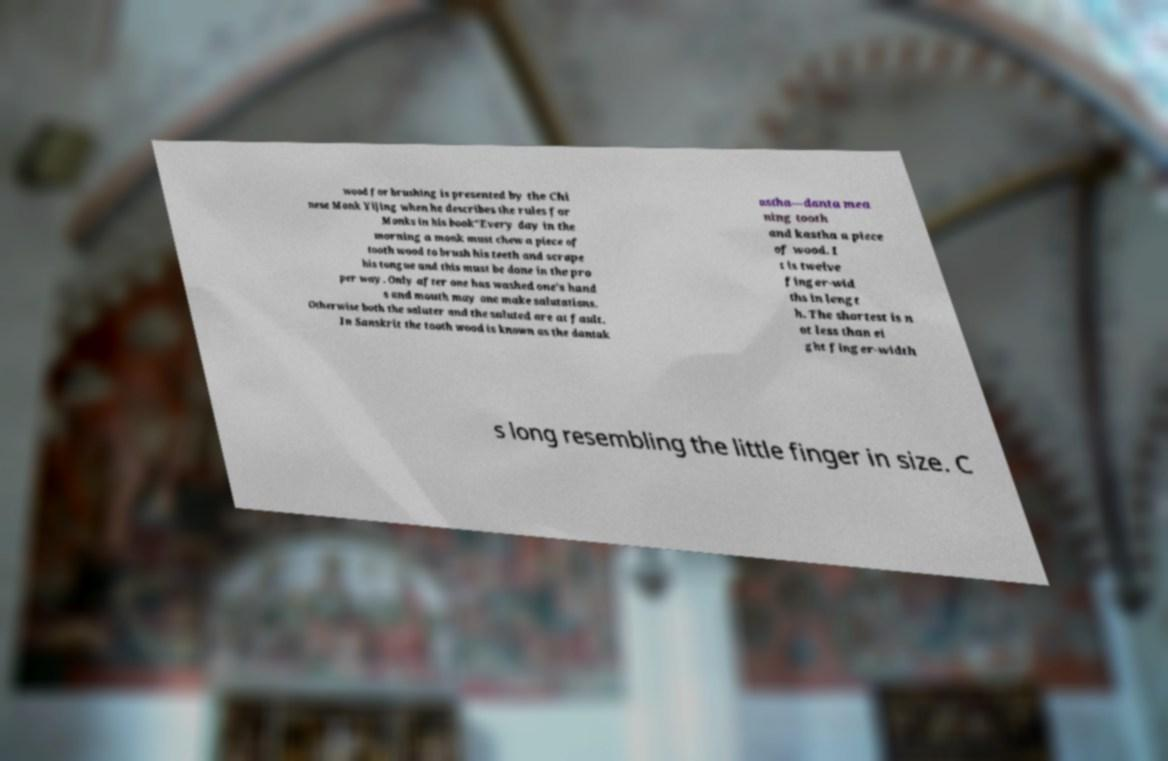Could you assist in decoding the text presented in this image and type it out clearly? wood for brushing is presented by the Chi nese Monk Yijing when he describes the rules for Monks in his book"Every day in the morning a monk must chew a piece of tooth wood to brush his teeth and scrape his tongue and this must be done in the pro per way. Only after one has washed one’s hand s and mouth may one make salutations. Otherwise both the saluter and the saluted are at fault. In Sanskrit the tooth wood is known as the dantak astha—danta mea ning tooth and kastha a piece of wood. I t is twelve finger-wid ths in lengt h. The shortest is n ot less than ei ght finger-width s long resembling the little finger in size. C 